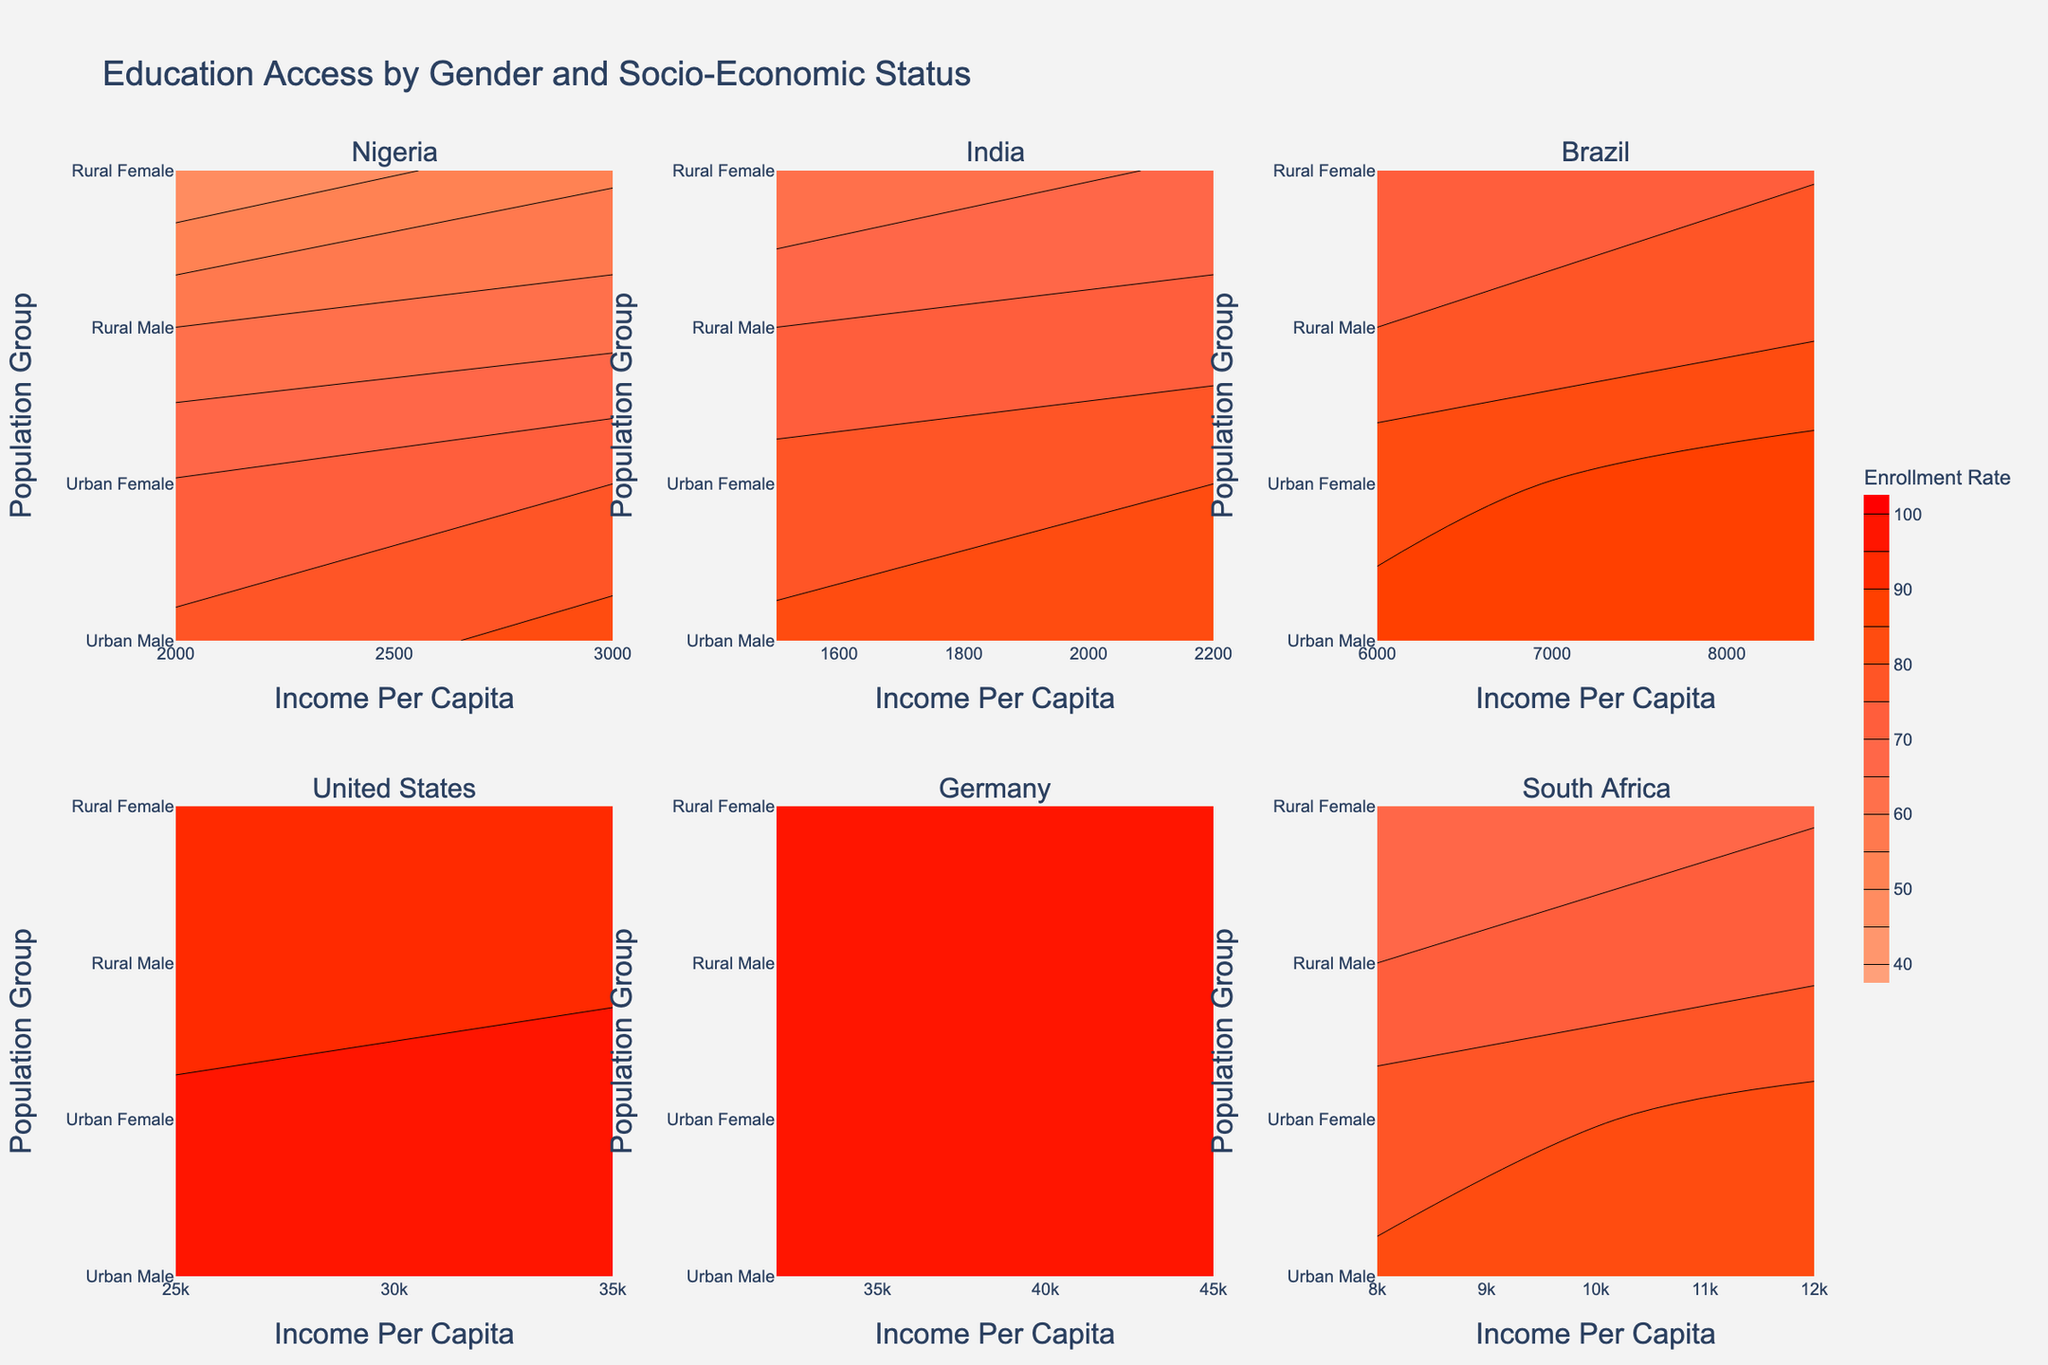What is the title of the plot? The title of the plot is likely displayed at the top of the figure. It gives a concise summary of the plot's content, which is "Education Access by Gender and Socio-Economic Status."
Answer: Education Access by Gender and Socio-Economic Status Which country has the highest enrollment rate for rural females? To find the country with the highest enrollment rate for rural females, look at the y-axis labels for "Rural Female" within each subplot and then identify the highest enrollment rate on the color gradient.
Answer: United States What is the enrollment rate difference between urban males and females in Nigeria? Compare the specified values for urban males and females in Nigeria from the subplot corresponding to Nigeria. Urban Male has 82 and Urban Female has 75. The difference is 82 - 75.
Answer: 7 How does the urban female enrollment rate in Germany compare to that in the United States? Look at the enrollment rate values for "Urban Female" in both the Germany and United States subplots. Germany has 97 and the United States has 96. Compare these values directly.
Answer: Germany has a higher enrollment rate by 1 Which country shows the lowest enrollment rate for rural males? Examine the y-axis labels for "Rural Male" and the associated enrollment rate on the color gradient for each subplot. The lowest value can be identified visually.
Answer: Nigeria What is the income per capita range covered in the contour plots? By looking at the x-axes of all subplots, identify the lowest and highest points of the income per capita range. The range extends from 1500 to 45000 based on the provided data.
Answer: 1500 to 45000 How does India's rural female enrollment rate compare to South Africa's rural female enrollment rate? In the subplots for India and South Africa, compare the enrollment rate values for "Rural Female." India has 60, while South Africa has 65.
Answer: South Africa’s rural female enrollment rate is higher by 5 Are there any countries where the enrollment rate for urban males is lower than for rural males? Compare the enrollment rates within each country's subplot for "Urban Male" and "Rural Male." No countries have urban males with lower rates.
Answer: No What is the enrollment rate for urban males in Brazil, and how does it compare to rural males in the same country? Check the subplot for Brazil and identify the enrollment rate values for "Urban Male" and "Rural Male." Urban Male is 90, and Rural Male is 75. The difference is 90 - 75.
Answer: Urban males have a higher enrollment rate by 15 Which population group in Nigeria has the lowest enrollment rate and what is it? In the Nigeria subplot, look at the enrollment rate values across all population groups and identify the lowest one. "Rural Female" has the lowest enrollment rate at 45.
Answer: Rural Female, 45 